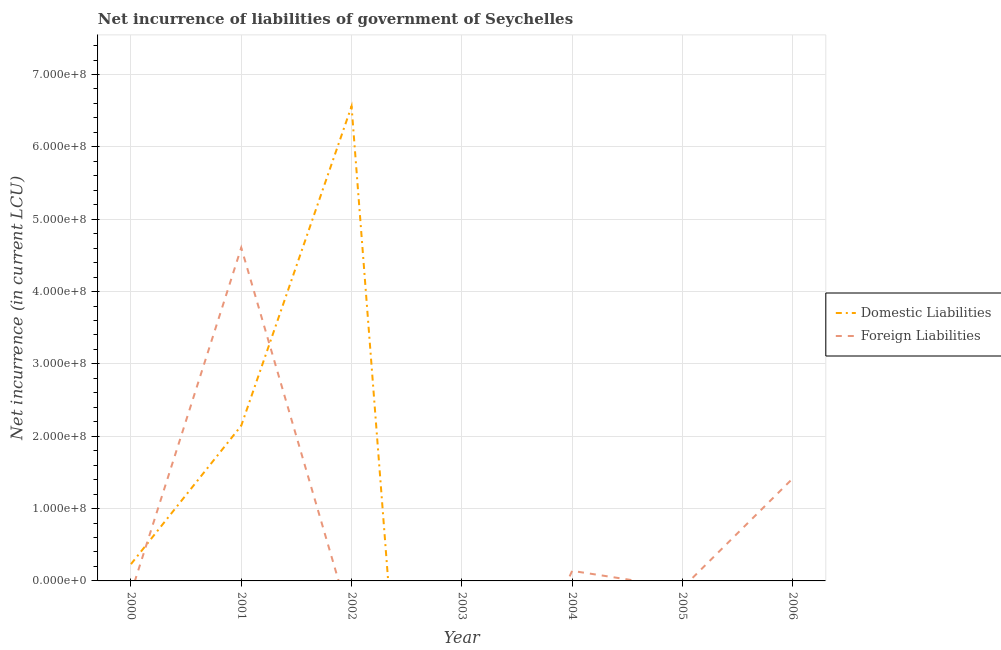How many different coloured lines are there?
Offer a terse response. 2. Does the line corresponding to net incurrence of foreign liabilities intersect with the line corresponding to net incurrence of domestic liabilities?
Give a very brief answer. Yes. Is the number of lines equal to the number of legend labels?
Your response must be concise. No. What is the net incurrence of foreign liabilities in 2001?
Give a very brief answer. 4.61e+08. Across all years, what is the maximum net incurrence of foreign liabilities?
Ensure brevity in your answer.  4.61e+08. Across all years, what is the minimum net incurrence of domestic liabilities?
Make the answer very short. 0. In which year was the net incurrence of foreign liabilities maximum?
Give a very brief answer. 2001. What is the total net incurrence of foreign liabilities in the graph?
Offer a very short reply. 6.16e+08. What is the difference between the net incurrence of domestic liabilities in 2000 and that in 2001?
Your answer should be very brief. -1.91e+08. What is the difference between the net incurrence of foreign liabilities in 2004 and the net incurrence of domestic liabilities in 2006?
Offer a terse response. 1.39e+07. What is the average net incurrence of domestic liabilities per year?
Offer a terse response. 1.28e+08. In the year 2001, what is the difference between the net incurrence of domestic liabilities and net incurrence of foreign liabilities?
Give a very brief answer. -2.46e+08. Is the net incurrence of domestic liabilities in 2001 less than that in 2002?
Your response must be concise. Yes. What is the difference between the highest and the second highest net incurrence of foreign liabilities?
Your response must be concise. 3.19e+08. What is the difference between the highest and the lowest net incurrence of domestic liabilities?
Give a very brief answer. 6.56e+08. Is the net incurrence of foreign liabilities strictly greater than the net incurrence of domestic liabilities over the years?
Your response must be concise. No. Are the values on the major ticks of Y-axis written in scientific E-notation?
Make the answer very short. Yes. Does the graph contain any zero values?
Ensure brevity in your answer.  Yes. How are the legend labels stacked?
Your response must be concise. Vertical. What is the title of the graph?
Offer a very short reply. Net incurrence of liabilities of government of Seychelles. Does "Education" appear as one of the legend labels in the graph?
Provide a short and direct response. No. What is the label or title of the Y-axis?
Your answer should be very brief. Net incurrence (in current LCU). What is the Net incurrence (in current LCU) of Domestic Liabilities in 2000?
Offer a very short reply. 2.32e+07. What is the Net incurrence (in current LCU) in Foreign Liabilities in 2000?
Ensure brevity in your answer.  0. What is the Net incurrence (in current LCU) in Domestic Liabilities in 2001?
Provide a succinct answer. 2.15e+08. What is the Net incurrence (in current LCU) in Foreign Liabilities in 2001?
Ensure brevity in your answer.  4.61e+08. What is the Net incurrence (in current LCU) of Domestic Liabilities in 2002?
Provide a short and direct response. 6.56e+08. What is the Net incurrence (in current LCU) of Foreign Liabilities in 2002?
Make the answer very short. 0. What is the Net incurrence (in current LCU) of Domestic Liabilities in 2004?
Ensure brevity in your answer.  0. What is the Net incurrence (in current LCU) in Foreign Liabilities in 2004?
Make the answer very short. 1.39e+07. What is the Net incurrence (in current LCU) of Domestic Liabilities in 2006?
Provide a short and direct response. 0. What is the Net incurrence (in current LCU) in Foreign Liabilities in 2006?
Provide a succinct answer. 1.42e+08. Across all years, what is the maximum Net incurrence (in current LCU) in Domestic Liabilities?
Your response must be concise. 6.56e+08. Across all years, what is the maximum Net incurrence (in current LCU) in Foreign Liabilities?
Provide a succinct answer. 4.61e+08. Across all years, what is the minimum Net incurrence (in current LCU) in Domestic Liabilities?
Ensure brevity in your answer.  0. What is the total Net incurrence (in current LCU) of Domestic Liabilities in the graph?
Your answer should be compact. 8.94e+08. What is the total Net incurrence (in current LCU) of Foreign Liabilities in the graph?
Keep it short and to the point. 6.16e+08. What is the difference between the Net incurrence (in current LCU) of Domestic Liabilities in 2000 and that in 2001?
Give a very brief answer. -1.91e+08. What is the difference between the Net incurrence (in current LCU) in Domestic Liabilities in 2000 and that in 2002?
Keep it short and to the point. -6.33e+08. What is the difference between the Net incurrence (in current LCU) of Domestic Liabilities in 2001 and that in 2002?
Your answer should be very brief. -4.41e+08. What is the difference between the Net incurrence (in current LCU) in Foreign Liabilities in 2001 and that in 2004?
Ensure brevity in your answer.  4.47e+08. What is the difference between the Net incurrence (in current LCU) of Foreign Liabilities in 2001 and that in 2006?
Make the answer very short. 3.19e+08. What is the difference between the Net incurrence (in current LCU) in Foreign Liabilities in 2004 and that in 2006?
Provide a short and direct response. -1.28e+08. What is the difference between the Net incurrence (in current LCU) in Domestic Liabilities in 2000 and the Net incurrence (in current LCU) in Foreign Liabilities in 2001?
Your answer should be compact. -4.37e+08. What is the difference between the Net incurrence (in current LCU) in Domestic Liabilities in 2000 and the Net incurrence (in current LCU) in Foreign Liabilities in 2004?
Your answer should be very brief. 9.30e+06. What is the difference between the Net incurrence (in current LCU) in Domestic Liabilities in 2000 and the Net incurrence (in current LCU) in Foreign Liabilities in 2006?
Your answer should be very brief. -1.18e+08. What is the difference between the Net incurrence (in current LCU) in Domestic Liabilities in 2001 and the Net incurrence (in current LCU) in Foreign Liabilities in 2004?
Provide a short and direct response. 2.01e+08. What is the difference between the Net incurrence (in current LCU) in Domestic Liabilities in 2001 and the Net incurrence (in current LCU) in Foreign Liabilities in 2006?
Your answer should be compact. 7.30e+07. What is the difference between the Net incurrence (in current LCU) of Domestic Liabilities in 2002 and the Net incurrence (in current LCU) of Foreign Liabilities in 2004?
Keep it short and to the point. 6.42e+08. What is the difference between the Net incurrence (in current LCU) in Domestic Liabilities in 2002 and the Net incurrence (in current LCU) in Foreign Liabilities in 2006?
Give a very brief answer. 5.14e+08. What is the average Net incurrence (in current LCU) of Domestic Liabilities per year?
Your answer should be very brief. 1.28e+08. What is the average Net incurrence (in current LCU) of Foreign Liabilities per year?
Your answer should be compact. 8.80e+07. In the year 2001, what is the difference between the Net incurrence (in current LCU) of Domestic Liabilities and Net incurrence (in current LCU) of Foreign Liabilities?
Give a very brief answer. -2.46e+08. What is the ratio of the Net incurrence (in current LCU) of Domestic Liabilities in 2000 to that in 2001?
Give a very brief answer. 0.11. What is the ratio of the Net incurrence (in current LCU) in Domestic Liabilities in 2000 to that in 2002?
Ensure brevity in your answer.  0.04. What is the ratio of the Net incurrence (in current LCU) in Domestic Liabilities in 2001 to that in 2002?
Offer a very short reply. 0.33. What is the ratio of the Net incurrence (in current LCU) in Foreign Liabilities in 2001 to that in 2004?
Your response must be concise. 33.14. What is the ratio of the Net incurrence (in current LCU) of Foreign Liabilities in 2001 to that in 2006?
Your answer should be compact. 3.25. What is the ratio of the Net incurrence (in current LCU) in Foreign Liabilities in 2004 to that in 2006?
Make the answer very short. 0.1. What is the difference between the highest and the second highest Net incurrence (in current LCU) of Domestic Liabilities?
Offer a terse response. 4.41e+08. What is the difference between the highest and the second highest Net incurrence (in current LCU) of Foreign Liabilities?
Offer a very short reply. 3.19e+08. What is the difference between the highest and the lowest Net incurrence (in current LCU) of Domestic Liabilities?
Provide a short and direct response. 6.56e+08. What is the difference between the highest and the lowest Net incurrence (in current LCU) of Foreign Liabilities?
Keep it short and to the point. 4.61e+08. 